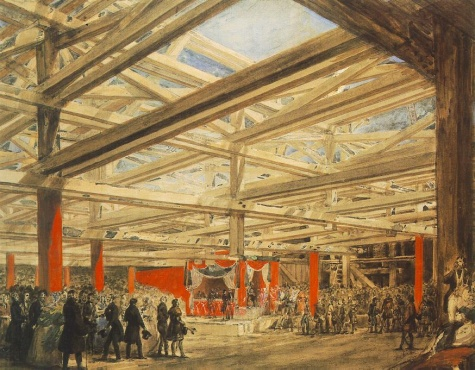What can you infer about the event occurring in the hall? Given the grand architecture of the hall, the diverse turnout of people, and the ceremonial throne on the stage, it's likely that the event is a significant societal gathering, possibly a royal court meeting or a major civic or political ceremony. The presence of various social classes and the structured setup suggest a planned and important occasion, perhaps involving speeches, announcements, or celebrations pertinent to the community or state. 